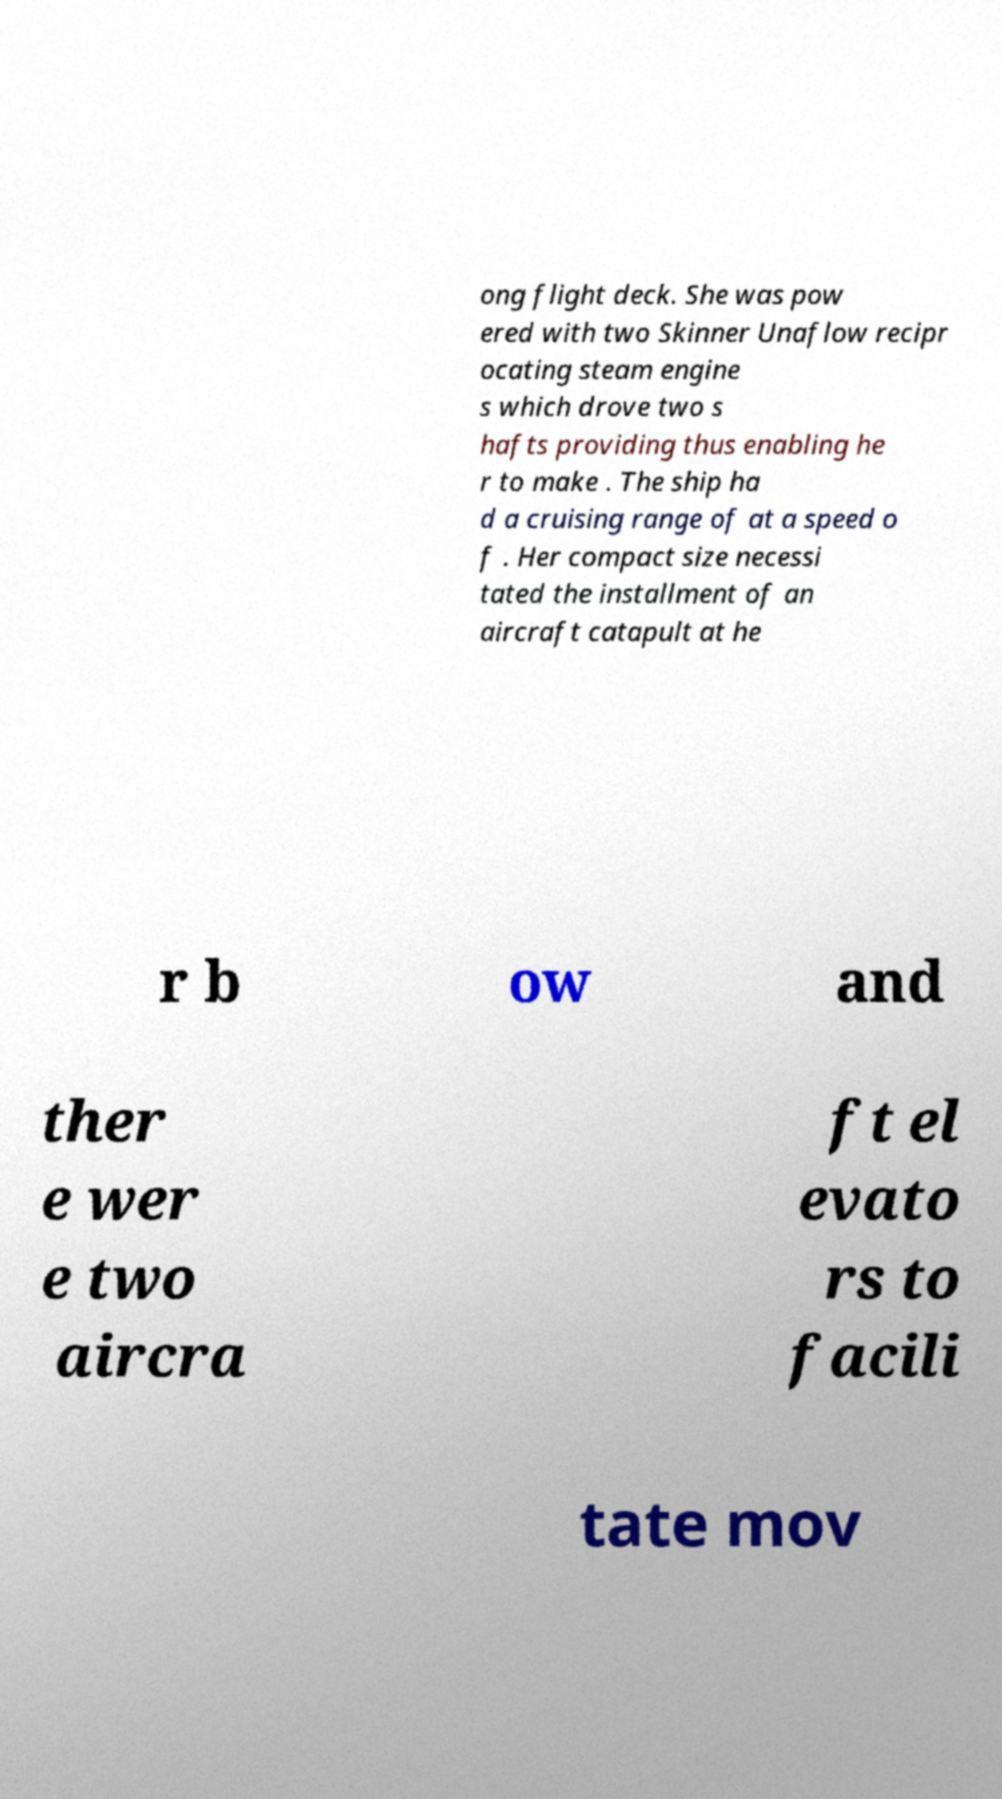Can you accurately transcribe the text from the provided image for me? ong flight deck. She was pow ered with two Skinner Unaflow recipr ocating steam engine s which drove two s hafts providing thus enabling he r to make . The ship ha d a cruising range of at a speed o f . Her compact size necessi tated the installment of an aircraft catapult at he r b ow and ther e wer e two aircra ft el evato rs to facili tate mov 